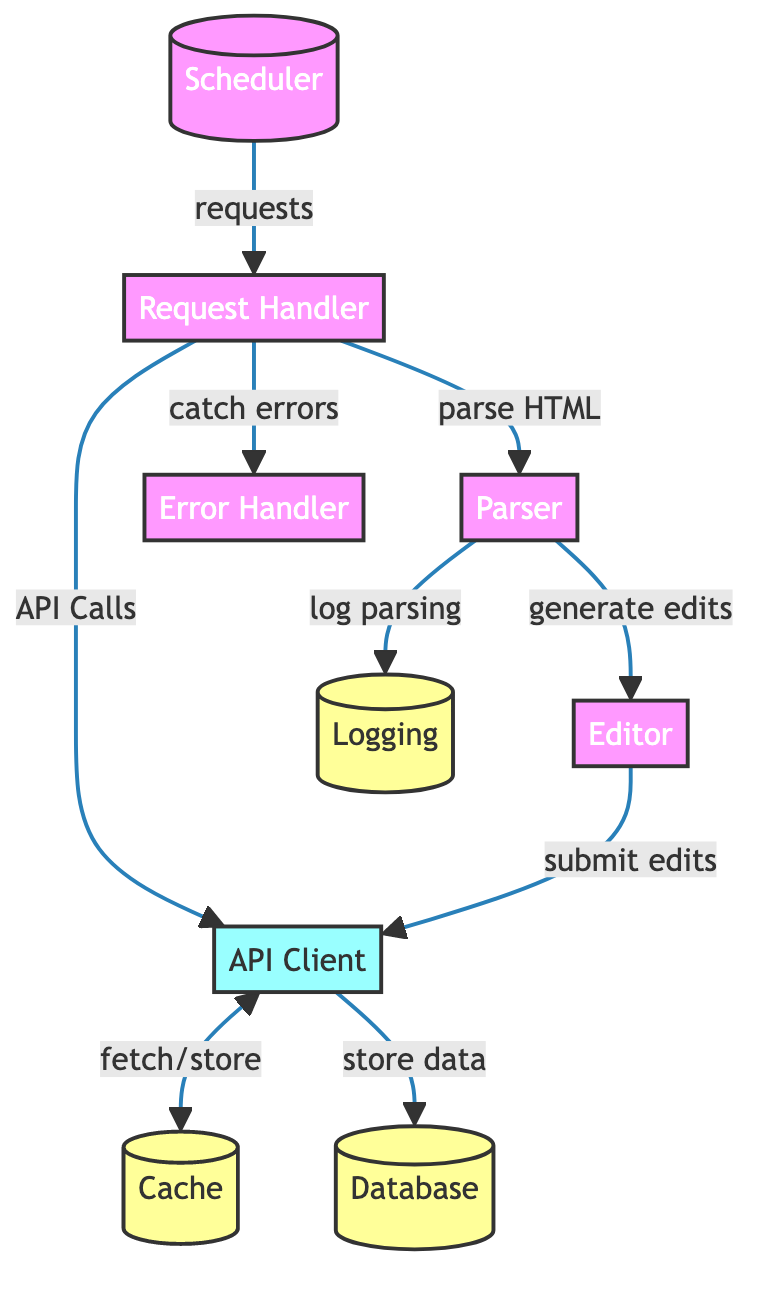What is the first component in the flowchart? The first component listed in the flowchart is the "Scheduler," which initiates the process by requesting tasks to be handled.
Answer: Scheduler How many storage components are present in the diagram? There are three storage components identified in the diagram: "Cache," "Logging," and "Database."
Answer: 3 What is the output of the "Parser"? The "Parser" generates edits that are produced after parsing the HTML from the requests.
Answer: Generate edits Which component catches errors in the process? The "Error Handler" component is responsible for catching errors that may occur during the process.
Answer: Error Handler What does the "API Client" do with data after it receives it? The "API Client" is responsible for storing the data in the "Database" after performing API calls.
Answer: Store data What relationship exists between the "Request Handler" and the "Parser"? The "Request Handler" sends requests to the "Parser" to parse the HTML content received in response to user requests.
Answer: Parse HTML What type of calls does the "Request Handler" make? The "Request Handler" makes API calls to the "API Client" as part of processing the requests.
Answer: API Calls How does the "Parser" log its activity? The "Parser" logs its parsing activity by sending logs to the "Logging" storage component.
Answer: Log parsing What does the "Scheduler" do in the overall architecture? The "Scheduler" initiates the process by sending requests to the "Request Handler," thus coordinating the overall operation of the bot framework.
Answer: Requests 